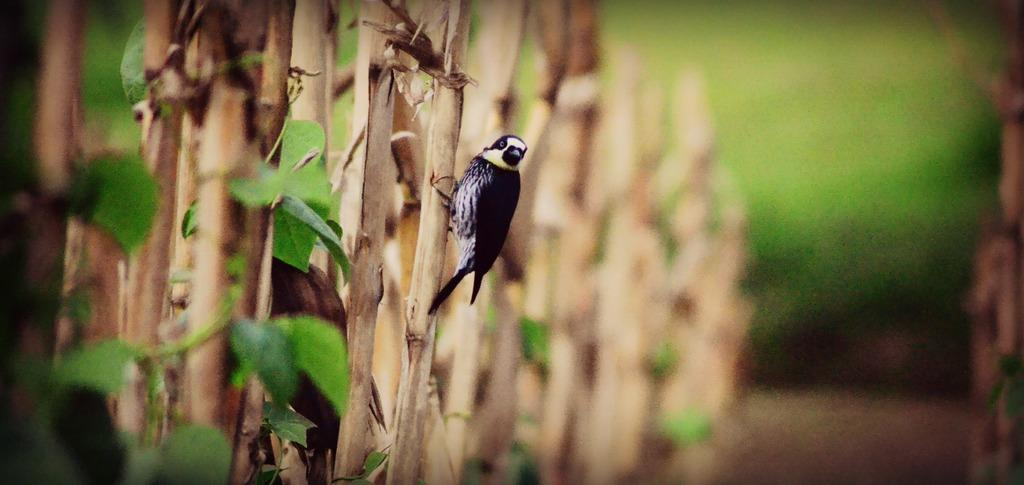What type of animal is in the image? There is a bird in the image. What colors can be seen on the bird? The bird has black and white coloring. Where is the bird located in the image? The bird is standing on a tree branch. What is the condition of the tree in the image? The tree has green leaves. How would you describe the background of the image? The background of the image is blurred. What type of chalk is the bird using to draw on the tree in the image? There is no chalk present in the image, and the bird is not drawing on the tree. 